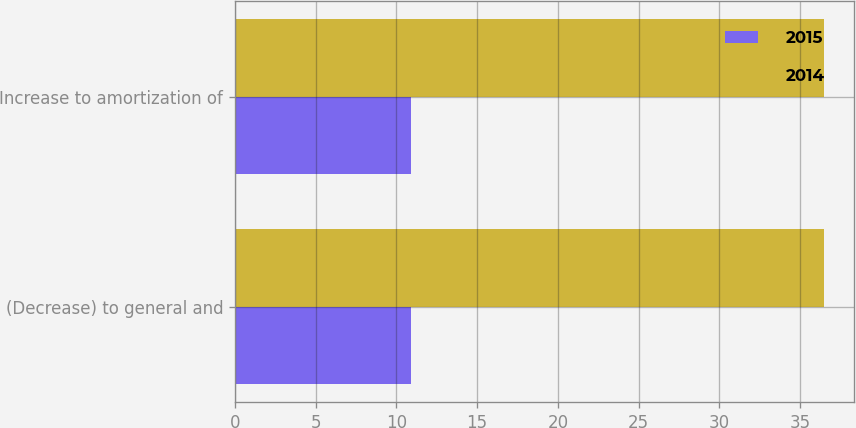Convert chart to OTSL. <chart><loc_0><loc_0><loc_500><loc_500><stacked_bar_chart><ecel><fcel>(Decrease) to general and<fcel>Increase to amortization of<nl><fcel>2015<fcel>10.9<fcel>10.9<nl><fcel>2014<fcel>36.5<fcel>36.5<nl></chart> 